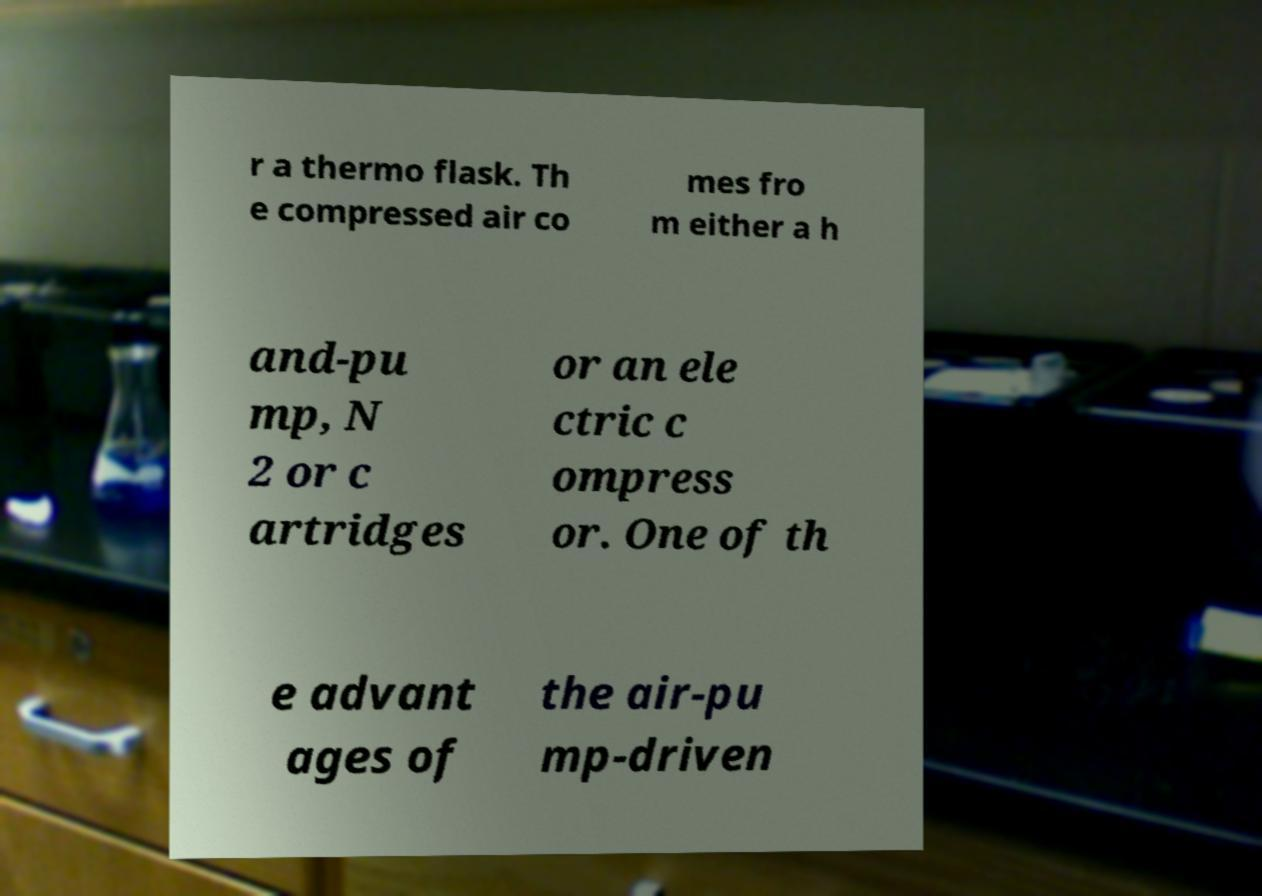Could you assist in decoding the text presented in this image and type it out clearly? r a thermo flask. Th e compressed air co mes fro m either a h and-pu mp, N 2 or c artridges or an ele ctric c ompress or. One of th e advant ages of the air-pu mp-driven 